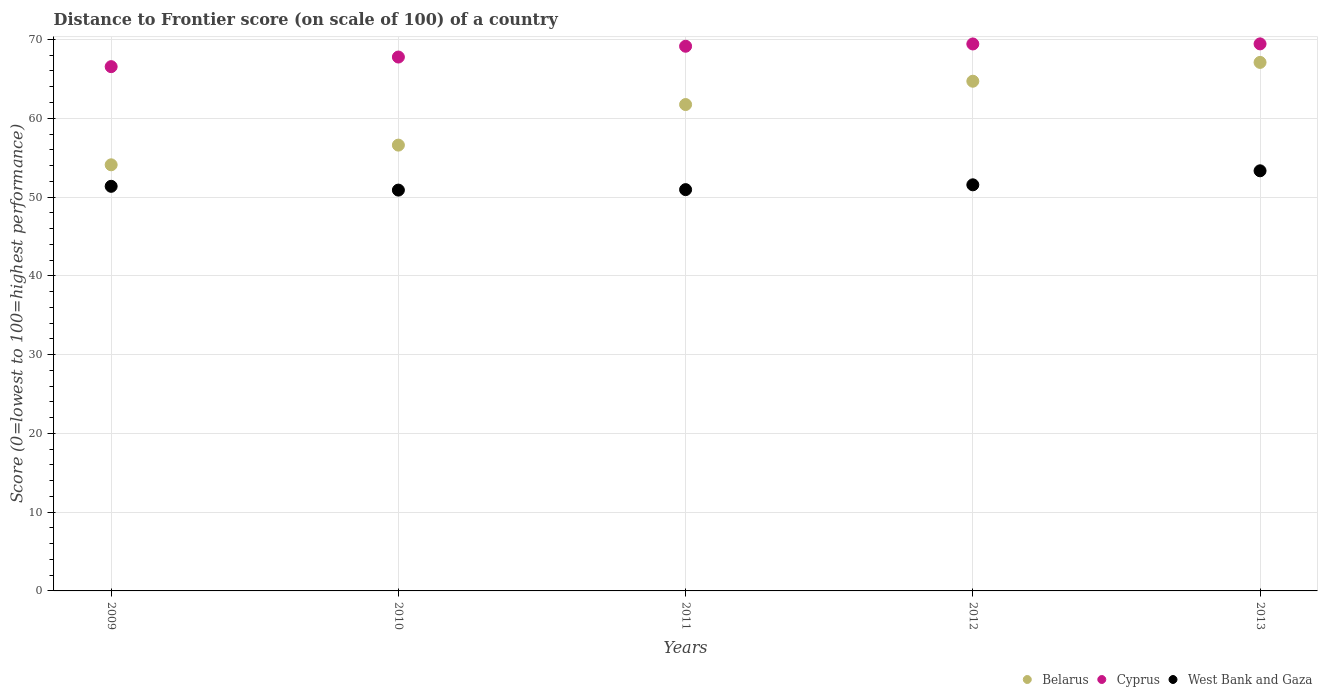How many different coloured dotlines are there?
Provide a succinct answer. 3. Is the number of dotlines equal to the number of legend labels?
Offer a very short reply. Yes. What is the distance to frontier score of in Cyprus in 2011?
Make the answer very short. 69.14. Across all years, what is the maximum distance to frontier score of in Belarus?
Your response must be concise. 67.09. Across all years, what is the minimum distance to frontier score of in Belarus?
Your answer should be very brief. 54.09. In which year was the distance to frontier score of in West Bank and Gaza maximum?
Give a very brief answer. 2013. What is the total distance to frontier score of in West Bank and Gaza in the graph?
Keep it short and to the point. 258.06. What is the difference between the distance to frontier score of in West Bank and Gaza in 2009 and that in 2013?
Your answer should be compact. -1.97. What is the difference between the distance to frontier score of in West Bank and Gaza in 2011 and the distance to frontier score of in Belarus in 2010?
Offer a very short reply. -5.65. What is the average distance to frontier score of in Belarus per year?
Provide a short and direct response. 60.84. In the year 2010, what is the difference between the distance to frontier score of in Belarus and distance to frontier score of in Cyprus?
Your answer should be very brief. -11.18. In how many years, is the distance to frontier score of in Cyprus greater than 14?
Offer a very short reply. 5. What is the ratio of the distance to frontier score of in Cyprus in 2012 to that in 2013?
Your answer should be very brief. 1. Is the difference between the distance to frontier score of in Belarus in 2009 and 2011 greater than the difference between the distance to frontier score of in Cyprus in 2009 and 2011?
Keep it short and to the point. No. What is the difference between the highest and the second highest distance to frontier score of in Belarus?
Keep it short and to the point. 2.39. What is the difference between the highest and the lowest distance to frontier score of in Belarus?
Your answer should be very brief. 13. Is the sum of the distance to frontier score of in Belarus in 2011 and 2013 greater than the maximum distance to frontier score of in Cyprus across all years?
Offer a terse response. Yes. Is it the case that in every year, the sum of the distance to frontier score of in West Bank and Gaza and distance to frontier score of in Cyprus  is greater than the distance to frontier score of in Belarus?
Give a very brief answer. Yes. Is the distance to frontier score of in Cyprus strictly greater than the distance to frontier score of in West Bank and Gaza over the years?
Provide a succinct answer. Yes. Is the distance to frontier score of in West Bank and Gaza strictly less than the distance to frontier score of in Belarus over the years?
Offer a terse response. Yes. How many dotlines are there?
Provide a short and direct response. 3. Does the graph contain any zero values?
Your answer should be compact. No. Does the graph contain grids?
Your answer should be very brief. Yes. Where does the legend appear in the graph?
Make the answer very short. Bottom right. How are the legend labels stacked?
Provide a short and direct response. Horizontal. What is the title of the graph?
Keep it short and to the point. Distance to Frontier score (on scale of 100) of a country. What is the label or title of the Y-axis?
Give a very brief answer. Score (0=lowest to 100=highest performance). What is the Score (0=lowest to 100=highest performance) in Belarus in 2009?
Your answer should be compact. 54.09. What is the Score (0=lowest to 100=highest performance) of Cyprus in 2009?
Provide a short and direct response. 66.55. What is the Score (0=lowest to 100=highest performance) of West Bank and Gaza in 2009?
Your answer should be very brief. 51.36. What is the Score (0=lowest to 100=highest performance) in Belarus in 2010?
Your response must be concise. 56.59. What is the Score (0=lowest to 100=highest performance) in Cyprus in 2010?
Offer a very short reply. 67.77. What is the Score (0=lowest to 100=highest performance) of West Bank and Gaza in 2010?
Provide a succinct answer. 50.88. What is the Score (0=lowest to 100=highest performance) of Belarus in 2011?
Offer a terse response. 61.74. What is the Score (0=lowest to 100=highest performance) in Cyprus in 2011?
Your response must be concise. 69.14. What is the Score (0=lowest to 100=highest performance) in West Bank and Gaza in 2011?
Give a very brief answer. 50.94. What is the Score (0=lowest to 100=highest performance) in Belarus in 2012?
Keep it short and to the point. 64.7. What is the Score (0=lowest to 100=highest performance) in Cyprus in 2012?
Offer a very short reply. 69.43. What is the Score (0=lowest to 100=highest performance) in West Bank and Gaza in 2012?
Ensure brevity in your answer.  51.55. What is the Score (0=lowest to 100=highest performance) of Belarus in 2013?
Your response must be concise. 67.09. What is the Score (0=lowest to 100=highest performance) in Cyprus in 2013?
Provide a short and direct response. 69.44. What is the Score (0=lowest to 100=highest performance) in West Bank and Gaza in 2013?
Ensure brevity in your answer.  53.33. Across all years, what is the maximum Score (0=lowest to 100=highest performance) in Belarus?
Offer a very short reply. 67.09. Across all years, what is the maximum Score (0=lowest to 100=highest performance) of Cyprus?
Keep it short and to the point. 69.44. Across all years, what is the maximum Score (0=lowest to 100=highest performance) in West Bank and Gaza?
Your answer should be very brief. 53.33. Across all years, what is the minimum Score (0=lowest to 100=highest performance) in Belarus?
Provide a short and direct response. 54.09. Across all years, what is the minimum Score (0=lowest to 100=highest performance) of Cyprus?
Keep it short and to the point. 66.55. Across all years, what is the minimum Score (0=lowest to 100=highest performance) of West Bank and Gaza?
Keep it short and to the point. 50.88. What is the total Score (0=lowest to 100=highest performance) in Belarus in the graph?
Your answer should be very brief. 304.21. What is the total Score (0=lowest to 100=highest performance) of Cyprus in the graph?
Give a very brief answer. 342.33. What is the total Score (0=lowest to 100=highest performance) in West Bank and Gaza in the graph?
Keep it short and to the point. 258.06. What is the difference between the Score (0=lowest to 100=highest performance) in Belarus in 2009 and that in 2010?
Provide a succinct answer. -2.5. What is the difference between the Score (0=lowest to 100=highest performance) of Cyprus in 2009 and that in 2010?
Provide a succinct answer. -1.22. What is the difference between the Score (0=lowest to 100=highest performance) of West Bank and Gaza in 2009 and that in 2010?
Keep it short and to the point. 0.48. What is the difference between the Score (0=lowest to 100=highest performance) in Belarus in 2009 and that in 2011?
Your answer should be compact. -7.65. What is the difference between the Score (0=lowest to 100=highest performance) of Cyprus in 2009 and that in 2011?
Make the answer very short. -2.59. What is the difference between the Score (0=lowest to 100=highest performance) in West Bank and Gaza in 2009 and that in 2011?
Ensure brevity in your answer.  0.42. What is the difference between the Score (0=lowest to 100=highest performance) in Belarus in 2009 and that in 2012?
Provide a succinct answer. -10.61. What is the difference between the Score (0=lowest to 100=highest performance) in Cyprus in 2009 and that in 2012?
Provide a short and direct response. -2.88. What is the difference between the Score (0=lowest to 100=highest performance) of West Bank and Gaza in 2009 and that in 2012?
Offer a terse response. -0.19. What is the difference between the Score (0=lowest to 100=highest performance) in Belarus in 2009 and that in 2013?
Keep it short and to the point. -13. What is the difference between the Score (0=lowest to 100=highest performance) of Cyprus in 2009 and that in 2013?
Your response must be concise. -2.89. What is the difference between the Score (0=lowest to 100=highest performance) in West Bank and Gaza in 2009 and that in 2013?
Make the answer very short. -1.97. What is the difference between the Score (0=lowest to 100=highest performance) of Belarus in 2010 and that in 2011?
Keep it short and to the point. -5.15. What is the difference between the Score (0=lowest to 100=highest performance) in Cyprus in 2010 and that in 2011?
Offer a terse response. -1.37. What is the difference between the Score (0=lowest to 100=highest performance) in West Bank and Gaza in 2010 and that in 2011?
Offer a very short reply. -0.06. What is the difference between the Score (0=lowest to 100=highest performance) in Belarus in 2010 and that in 2012?
Offer a terse response. -8.11. What is the difference between the Score (0=lowest to 100=highest performance) in Cyprus in 2010 and that in 2012?
Make the answer very short. -1.66. What is the difference between the Score (0=lowest to 100=highest performance) in West Bank and Gaza in 2010 and that in 2012?
Offer a terse response. -0.67. What is the difference between the Score (0=lowest to 100=highest performance) in Cyprus in 2010 and that in 2013?
Offer a terse response. -1.67. What is the difference between the Score (0=lowest to 100=highest performance) in West Bank and Gaza in 2010 and that in 2013?
Provide a succinct answer. -2.45. What is the difference between the Score (0=lowest to 100=highest performance) of Belarus in 2011 and that in 2012?
Your answer should be very brief. -2.96. What is the difference between the Score (0=lowest to 100=highest performance) in Cyprus in 2011 and that in 2012?
Provide a short and direct response. -0.29. What is the difference between the Score (0=lowest to 100=highest performance) in West Bank and Gaza in 2011 and that in 2012?
Your answer should be compact. -0.61. What is the difference between the Score (0=lowest to 100=highest performance) of Belarus in 2011 and that in 2013?
Offer a terse response. -5.35. What is the difference between the Score (0=lowest to 100=highest performance) in Cyprus in 2011 and that in 2013?
Your answer should be compact. -0.3. What is the difference between the Score (0=lowest to 100=highest performance) of West Bank and Gaza in 2011 and that in 2013?
Ensure brevity in your answer.  -2.39. What is the difference between the Score (0=lowest to 100=highest performance) of Belarus in 2012 and that in 2013?
Provide a succinct answer. -2.39. What is the difference between the Score (0=lowest to 100=highest performance) in Cyprus in 2012 and that in 2013?
Your response must be concise. -0.01. What is the difference between the Score (0=lowest to 100=highest performance) in West Bank and Gaza in 2012 and that in 2013?
Make the answer very short. -1.78. What is the difference between the Score (0=lowest to 100=highest performance) in Belarus in 2009 and the Score (0=lowest to 100=highest performance) in Cyprus in 2010?
Give a very brief answer. -13.68. What is the difference between the Score (0=lowest to 100=highest performance) in Belarus in 2009 and the Score (0=lowest to 100=highest performance) in West Bank and Gaza in 2010?
Make the answer very short. 3.21. What is the difference between the Score (0=lowest to 100=highest performance) of Cyprus in 2009 and the Score (0=lowest to 100=highest performance) of West Bank and Gaza in 2010?
Offer a very short reply. 15.67. What is the difference between the Score (0=lowest to 100=highest performance) in Belarus in 2009 and the Score (0=lowest to 100=highest performance) in Cyprus in 2011?
Provide a succinct answer. -15.05. What is the difference between the Score (0=lowest to 100=highest performance) in Belarus in 2009 and the Score (0=lowest to 100=highest performance) in West Bank and Gaza in 2011?
Your response must be concise. 3.15. What is the difference between the Score (0=lowest to 100=highest performance) of Cyprus in 2009 and the Score (0=lowest to 100=highest performance) of West Bank and Gaza in 2011?
Make the answer very short. 15.61. What is the difference between the Score (0=lowest to 100=highest performance) of Belarus in 2009 and the Score (0=lowest to 100=highest performance) of Cyprus in 2012?
Provide a short and direct response. -15.34. What is the difference between the Score (0=lowest to 100=highest performance) of Belarus in 2009 and the Score (0=lowest to 100=highest performance) of West Bank and Gaza in 2012?
Make the answer very short. 2.54. What is the difference between the Score (0=lowest to 100=highest performance) in Cyprus in 2009 and the Score (0=lowest to 100=highest performance) in West Bank and Gaza in 2012?
Keep it short and to the point. 15. What is the difference between the Score (0=lowest to 100=highest performance) in Belarus in 2009 and the Score (0=lowest to 100=highest performance) in Cyprus in 2013?
Make the answer very short. -15.35. What is the difference between the Score (0=lowest to 100=highest performance) of Belarus in 2009 and the Score (0=lowest to 100=highest performance) of West Bank and Gaza in 2013?
Offer a very short reply. 0.76. What is the difference between the Score (0=lowest to 100=highest performance) of Cyprus in 2009 and the Score (0=lowest to 100=highest performance) of West Bank and Gaza in 2013?
Keep it short and to the point. 13.22. What is the difference between the Score (0=lowest to 100=highest performance) of Belarus in 2010 and the Score (0=lowest to 100=highest performance) of Cyprus in 2011?
Make the answer very short. -12.55. What is the difference between the Score (0=lowest to 100=highest performance) in Belarus in 2010 and the Score (0=lowest to 100=highest performance) in West Bank and Gaza in 2011?
Ensure brevity in your answer.  5.65. What is the difference between the Score (0=lowest to 100=highest performance) in Cyprus in 2010 and the Score (0=lowest to 100=highest performance) in West Bank and Gaza in 2011?
Offer a very short reply. 16.83. What is the difference between the Score (0=lowest to 100=highest performance) of Belarus in 2010 and the Score (0=lowest to 100=highest performance) of Cyprus in 2012?
Your answer should be very brief. -12.84. What is the difference between the Score (0=lowest to 100=highest performance) in Belarus in 2010 and the Score (0=lowest to 100=highest performance) in West Bank and Gaza in 2012?
Offer a very short reply. 5.04. What is the difference between the Score (0=lowest to 100=highest performance) of Cyprus in 2010 and the Score (0=lowest to 100=highest performance) of West Bank and Gaza in 2012?
Your response must be concise. 16.22. What is the difference between the Score (0=lowest to 100=highest performance) in Belarus in 2010 and the Score (0=lowest to 100=highest performance) in Cyprus in 2013?
Ensure brevity in your answer.  -12.85. What is the difference between the Score (0=lowest to 100=highest performance) in Belarus in 2010 and the Score (0=lowest to 100=highest performance) in West Bank and Gaza in 2013?
Offer a very short reply. 3.26. What is the difference between the Score (0=lowest to 100=highest performance) of Cyprus in 2010 and the Score (0=lowest to 100=highest performance) of West Bank and Gaza in 2013?
Give a very brief answer. 14.44. What is the difference between the Score (0=lowest to 100=highest performance) in Belarus in 2011 and the Score (0=lowest to 100=highest performance) in Cyprus in 2012?
Keep it short and to the point. -7.69. What is the difference between the Score (0=lowest to 100=highest performance) of Belarus in 2011 and the Score (0=lowest to 100=highest performance) of West Bank and Gaza in 2012?
Keep it short and to the point. 10.19. What is the difference between the Score (0=lowest to 100=highest performance) in Cyprus in 2011 and the Score (0=lowest to 100=highest performance) in West Bank and Gaza in 2012?
Give a very brief answer. 17.59. What is the difference between the Score (0=lowest to 100=highest performance) of Belarus in 2011 and the Score (0=lowest to 100=highest performance) of West Bank and Gaza in 2013?
Your answer should be very brief. 8.41. What is the difference between the Score (0=lowest to 100=highest performance) in Cyprus in 2011 and the Score (0=lowest to 100=highest performance) in West Bank and Gaza in 2013?
Your answer should be compact. 15.81. What is the difference between the Score (0=lowest to 100=highest performance) of Belarus in 2012 and the Score (0=lowest to 100=highest performance) of Cyprus in 2013?
Give a very brief answer. -4.74. What is the difference between the Score (0=lowest to 100=highest performance) of Belarus in 2012 and the Score (0=lowest to 100=highest performance) of West Bank and Gaza in 2013?
Offer a very short reply. 11.37. What is the average Score (0=lowest to 100=highest performance) of Belarus per year?
Your answer should be compact. 60.84. What is the average Score (0=lowest to 100=highest performance) in Cyprus per year?
Provide a short and direct response. 68.47. What is the average Score (0=lowest to 100=highest performance) of West Bank and Gaza per year?
Your response must be concise. 51.61. In the year 2009, what is the difference between the Score (0=lowest to 100=highest performance) of Belarus and Score (0=lowest to 100=highest performance) of Cyprus?
Keep it short and to the point. -12.46. In the year 2009, what is the difference between the Score (0=lowest to 100=highest performance) in Belarus and Score (0=lowest to 100=highest performance) in West Bank and Gaza?
Provide a short and direct response. 2.73. In the year 2009, what is the difference between the Score (0=lowest to 100=highest performance) in Cyprus and Score (0=lowest to 100=highest performance) in West Bank and Gaza?
Offer a terse response. 15.19. In the year 2010, what is the difference between the Score (0=lowest to 100=highest performance) in Belarus and Score (0=lowest to 100=highest performance) in Cyprus?
Your response must be concise. -11.18. In the year 2010, what is the difference between the Score (0=lowest to 100=highest performance) in Belarus and Score (0=lowest to 100=highest performance) in West Bank and Gaza?
Offer a terse response. 5.71. In the year 2010, what is the difference between the Score (0=lowest to 100=highest performance) of Cyprus and Score (0=lowest to 100=highest performance) of West Bank and Gaza?
Give a very brief answer. 16.89. In the year 2011, what is the difference between the Score (0=lowest to 100=highest performance) in Cyprus and Score (0=lowest to 100=highest performance) in West Bank and Gaza?
Make the answer very short. 18.2. In the year 2012, what is the difference between the Score (0=lowest to 100=highest performance) in Belarus and Score (0=lowest to 100=highest performance) in Cyprus?
Provide a short and direct response. -4.73. In the year 2012, what is the difference between the Score (0=lowest to 100=highest performance) in Belarus and Score (0=lowest to 100=highest performance) in West Bank and Gaza?
Ensure brevity in your answer.  13.15. In the year 2012, what is the difference between the Score (0=lowest to 100=highest performance) in Cyprus and Score (0=lowest to 100=highest performance) in West Bank and Gaza?
Your answer should be very brief. 17.88. In the year 2013, what is the difference between the Score (0=lowest to 100=highest performance) in Belarus and Score (0=lowest to 100=highest performance) in Cyprus?
Give a very brief answer. -2.35. In the year 2013, what is the difference between the Score (0=lowest to 100=highest performance) of Belarus and Score (0=lowest to 100=highest performance) of West Bank and Gaza?
Keep it short and to the point. 13.76. In the year 2013, what is the difference between the Score (0=lowest to 100=highest performance) of Cyprus and Score (0=lowest to 100=highest performance) of West Bank and Gaza?
Keep it short and to the point. 16.11. What is the ratio of the Score (0=lowest to 100=highest performance) of Belarus in 2009 to that in 2010?
Your response must be concise. 0.96. What is the ratio of the Score (0=lowest to 100=highest performance) in West Bank and Gaza in 2009 to that in 2010?
Ensure brevity in your answer.  1.01. What is the ratio of the Score (0=lowest to 100=highest performance) of Belarus in 2009 to that in 2011?
Give a very brief answer. 0.88. What is the ratio of the Score (0=lowest to 100=highest performance) in Cyprus in 2009 to that in 2011?
Offer a very short reply. 0.96. What is the ratio of the Score (0=lowest to 100=highest performance) in West Bank and Gaza in 2009 to that in 2011?
Your answer should be compact. 1.01. What is the ratio of the Score (0=lowest to 100=highest performance) of Belarus in 2009 to that in 2012?
Give a very brief answer. 0.84. What is the ratio of the Score (0=lowest to 100=highest performance) of Cyprus in 2009 to that in 2012?
Offer a terse response. 0.96. What is the ratio of the Score (0=lowest to 100=highest performance) of Belarus in 2009 to that in 2013?
Provide a succinct answer. 0.81. What is the ratio of the Score (0=lowest to 100=highest performance) in Cyprus in 2009 to that in 2013?
Keep it short and to the point. 0.96. What is the ratio of the Score (0=lowest to 100=highest performance) of West Bank and Gaza in 2009 to that in 2013?
Offer a terse response. 0.96. What is the ratio of the Score (0=lowest to 100=highest performance) of Belarus in 2010 to that in 2011?
Offer a terse response. 0.92. What is the ratio of the Score (0=lowest to 100=highest performance) of Cyprus in 2010 to that in 2011?
Make the answer very short. 0.98. What is the ratio of the Score (0=lowest to 100=highest performance) of West Bank and Gaza in 2010 to that in 2011?
Your answer should be very brief. 1. What is the ratio of the Score (0=lowest to 100=highest performance) in Belarus in 2010 to that in 2012?
Offer a terse response. 0.87. What is the ratio of the Score (0=lowest to 100=highest performance) in Cyprus in 2010 to that in 2012?
Keep it short and to the point. 0.98. What is the ratio of the Score (0=lowest to 100=highest performance) of West Bank and Gaza in 2010 to that in 2012?
Ensure brevity in your answer.  0.99. What is the ratio of the Score (0=lowest to 100=highest performance) of Belarus in 2010 to that in 2013?
Provide a succinct answer. 0.84. What is the ratio of the Score (0=lowest to 100=highest performance) of West Bank and Gaza in 2010 to that in 2013?
Provide a short and direct response. 0.95. What is the ratio of the Score (0=lowest to 100=highest performance) in Belarus in 2011 to that in 2012?
Your answer should be very brief. 0.95. What is the ratio of the Score (0=lowest to 100=highest performance) of West Bank and Gaza in 2011 to that in 2012?
Your response must be concise. 0.99. What is the ratio of the Score (0=lowest to 100=highest performance) in Belarus in 2011 to that in 2013?
Provide a succinct answer. 0.92. What is the ratio of the Score (0=lowest to 100=highest performance) in Cyprus in 2011 to that in 2013?
Your answer should be very brief. 1. What is the ratio of the Score (0=lowest to 100=highest performance) of West Bank and Gaza in 2011 to that in 2013?
Your answer should be very brief. 0.96. What is the ratio of the Score (0=lowest to 100=highest performance) in Belarus in 2012 to that in 2013?
Make the answer very short. 0.96. What is the ratio of the Score (0=lowest to 100=highest performance) in Cyprus in 2012 to that in 2013?
Make the answer very short. 1. What is the ratio of the Score (0=lowest to 100=highest performance) in West Bank and Gaza in 2012 to that in 2013?
Your response must be concise. 0.97. What is the difference between the highest and the second highest Score (0=lowest to 100=highest performance) in Belarus?
Your answer should be very brief. 2.39. What is the difference between the highest and the second highest Score (0=lowest to 100=highest performance) in Cyprus?
Offer a very short reply. 0.01. What is the difference between the highest and the second highest Score (0=lowest to 100=highest performance) in West Bank and Gaza?
Your response must be concise. 1.78. What is the difference between the highest and the lowest Score (0=lowest to 100=highest performance) of Belarus?
Your answer should be compact. 13. What is the difference between the highest and the lowest Score (0=lowest to 100=highest performance) of Cyprus?
Provide a succinct answer. 2.89. What is the difference between the highest and the lowest Score (0=lowest to 100=highest performance) of West Bank and Gaza?
Offer a very short reply. 2.45. 